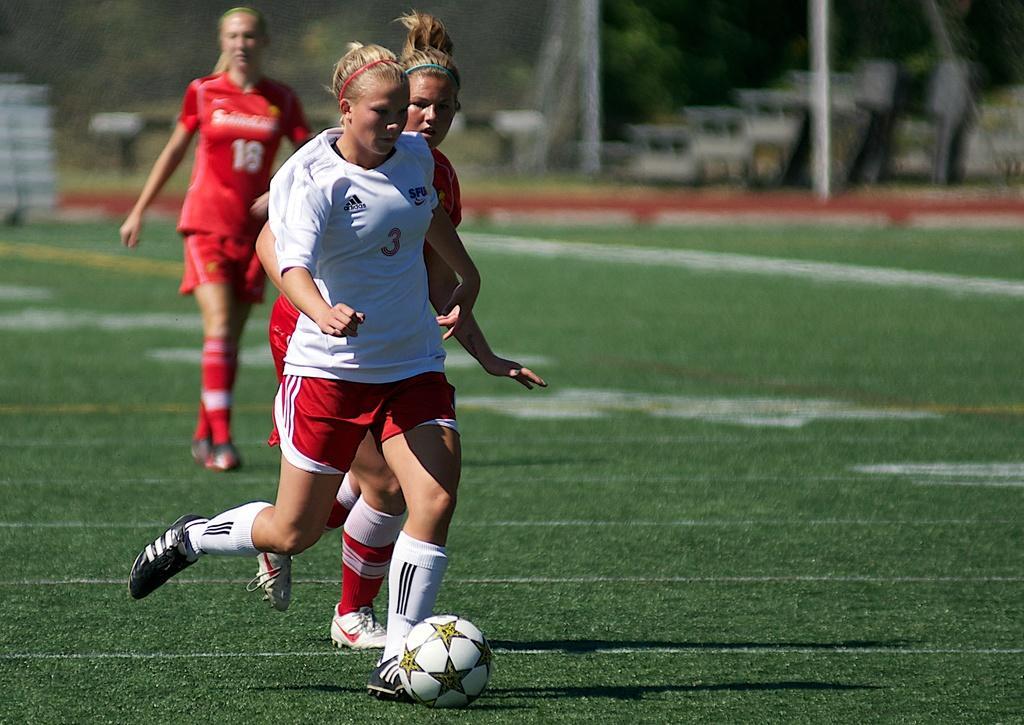Can you describe this image briefly? In this picture there are group of girls those who are playing the foot ball, on the grass floor, there are trees around the area of the image, it seems to be a play ground. 